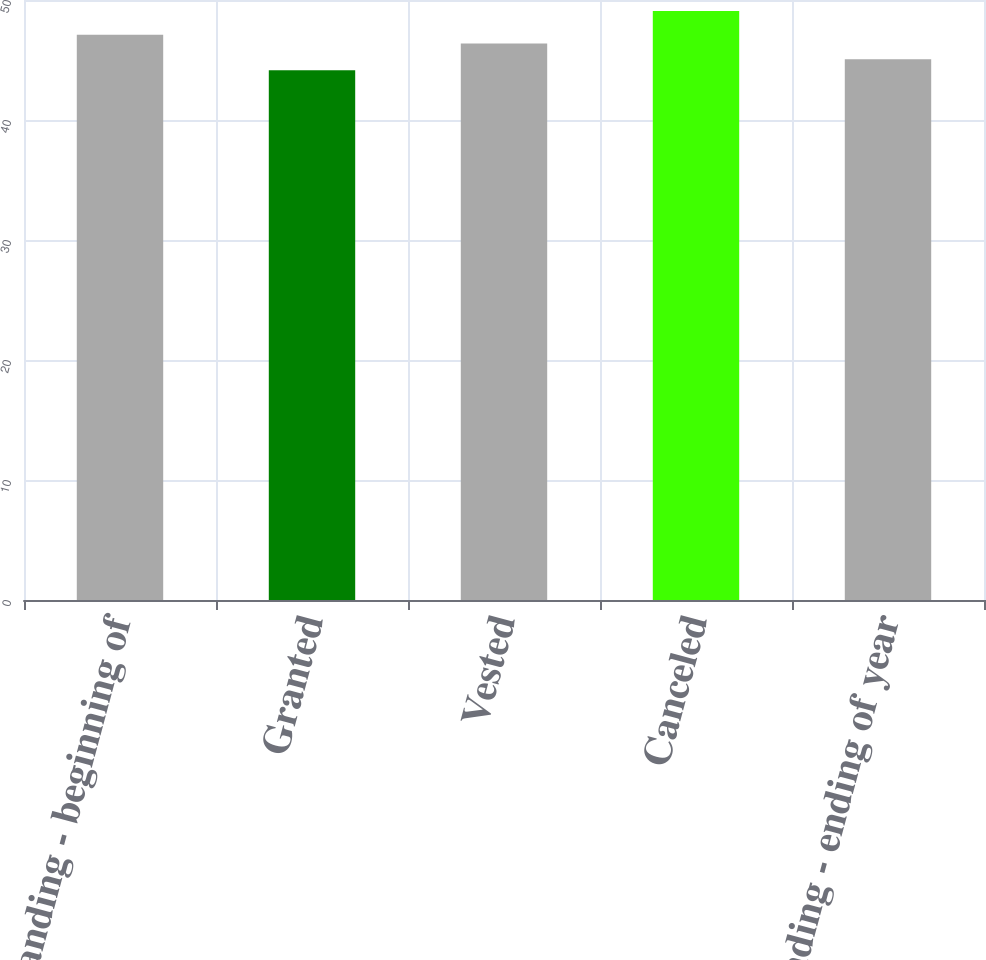Convert chart. <chart><loc_0><loc_0><loc_500><loc_500><bar_chart><fcel>Outstanding - beginning of<fcel>Granted<fcel>Vested<fcel>Canceled<fcel>Outstanding - ending of year<nl><fcel>47.1<fcel>44.14<fcel>46.38<fcel>49.09<fcel>45.06<nl></chart> 